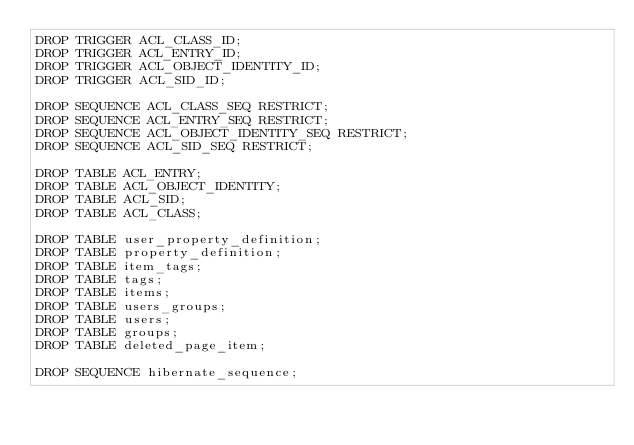<code> <loc_0><loc_0><loc_500><loc_500><_SQL_>DROP TRIGGER ACL_CLASS_ID;
DROP TRIGGER ACL_ENTRY_ID;
DROP TRIGGER ACL_OBJECT_IDENTITY_ID;
DROP TRIGGER ACL_SID_ID;

DROP SEQUENCE ACL_CLASS_SEQ RESTRICT;
DROP SEQUENCE ACL_ENTRY_SEQ RESTRICT;
DROP SEQUENCE ACL_OBJECT_IDENTITY_SEQ RESTRICT;
DROP SEQUENCE ACL_SID_SEQ RESTRICT;

DROP TABLE ACL_ENTRY;
DROP TABLE ACL_OBJECT_IDENTITY;
DROP TABLE ACL_SID;
DROP TABLE ACL_CLASS;

DROP TABLE user_property_definition;
DROP TABLE property_definition;
DROP TABLE item_tags;
DROP TABLE tags;
DROP TABLE items;
DROP TABLE users_groups;
DROP TABLE users;
DROP TABLE groups;
DROP TABLE deleted_page_item;

DROP SEQUENCE hibernate_sequence;
</code> 